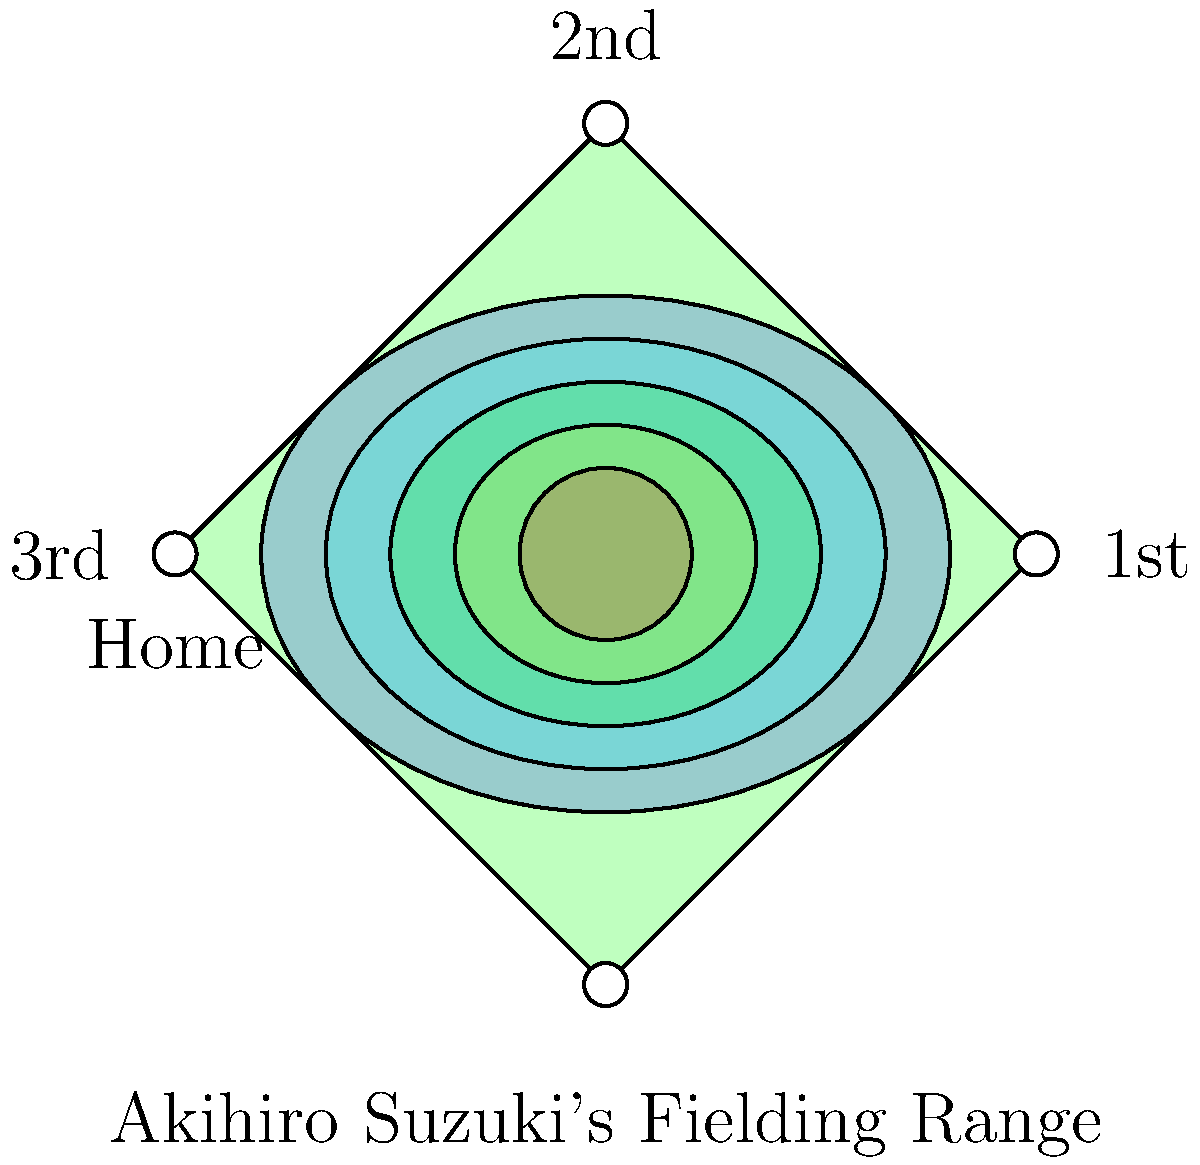Based on the heat map overlay of Akihiro Suzuki's fielding range on a baseball diamond, which area represents his strongest defensive coverage, and how might this impact the team's overall defensive strategy? To answer this question, we need to analyze the heat map overlay on the baseball diamond representing Akihiro Suzuki's fielding range:

1. The heat map uses color gradients to represent the intensity of Suzuki's defensive coverage.
2. The colors range from blue (least coverage) to red (most coverage).
3. The center of the heat map is the most intense red color, indicating the strongest defensive coverage.
4. This central area is located slightly behind second base, extending towards shortstop and second base positions.
5. The heat map shows a symmetrical pattern, suggesting Suzuki has equal range to his left and right.
6. The elongated shape of the heat map indicates better range forward and backward compared to side-to-side movement.

Impact on team's defensive strategy:
1. Suzuki's strong coverage in the middle infield allows for flexible positioning of other infielders.
2. The team can shift the shortstop or second baseman to cover more ground in areas where Suzuki's range is weaker.
3. Outfielders can play deeper, knowing Suzuki can cover more ground on shallow fly balls.
4. The pitcher may be more comfortable inducing ground balls up the middle, knowing Suzuki's strong presence there.
5. The team might employ more aggressive defensive shifts against pull hitters, relying on Suzuki to cover a larger area of the infield.
Answer: Central infield behind second base; allows for flexible infielder positioning and deeper outfield play. 